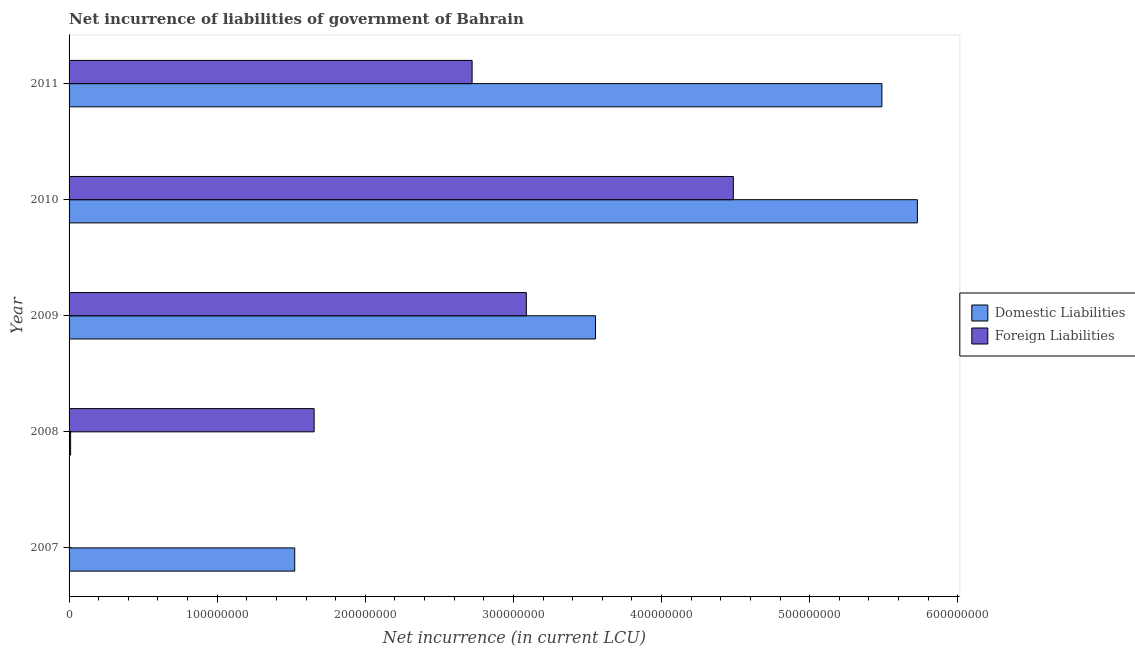How many different coloured bars are there?
Your answer should be compact. 2. How many bars are there on the 5th tick from the bottom?
Keep it short and to the point. 2. What is the net incurrence of domestic liabilities in 2011?
Provide a succinct answer. 5.49e+08. Across all years, what is the maximum net incurrence of foreign liabilities?
Provide a succinct answer. 4.48e+08. What is the total net incurrence of foreign liabilities in the graph?
Your answer should be very brief. 1.19e+09. What is the difference between the net incurrence of domestic liabilities in 2007 and that in 2008?
Keep it short and to the point. 1.51e+08. What is the difference between the net incurrence of domestic liabilities in 2008 and the net incurrence of foreign liabilities in 2010?
Provide a short and direct response. -4.47e+08. What is the average net incurrence of foreign liabilities per year?
Your answer should be compact. 2.39e+08. In the year 2009, what is the difference between the net incurrence of foreign liabilities and net incurrence of domestic liabilities?
Your answer should be compact. -4.67e+07. What is the ratio of the net incurrence of domestic liabilities in 2008 to that in 2011?
Your answer should be compact. 0. Is the net incurrence of foreign liabilities in 2010 less than that in 2011?
Offer a terse response. No. Is the difference between the net incurrence of domestic liabilities in 2009 and 2011 greater than the difference between the net incurrence of foreign liabilities in 2009 and 2011?
Provide a short and direct response. No. What is the difference between the highest and the second highest net incurrence of domestic liabilities?
Make the answer very short. 2.40e+07. What is the difference between the highest and the lowest net incurrence of domestic liabilities?
Ensure brevity in your answer.  5.72e+08. Is the sum of the net incurrence of domestic liabilities in 2009 and 2011 greater than the maximum net incurrence of foreign liabilities across all years?
Provide a short and direct response. Yes. How many years are there in the graph?
Ensure brevity in your answer.  5. Does the graph contain any zero values?
Keep it short and to the point. Yes. Where does the legend appear in the graph?
Provide a succinct answer. Center right. What is the title of the graph?
Your answer should be very brief. Net incurrence of liabilities of government of Bahrain. What is the label or title of the X-axis?
Your response must be concise. Net incurrence (in current LCU). What is the Net incurrence (in current LCU) in Domestic Liabilities in 2007?
Your answer should be compact. 1.52e+08. What is the Net incurrence (in current LCU) of Domestic Liabilities in 2008?
Your answer should be very brief. 1.04e+06. What is the Net incurrence (in current LCU) of Foreign Liabilities in 2008?
Keep it short and to the point. 1.65e+08. What is the Net incurrence (in current LCU) of Domestic Liabilities in 2009?
Make the answer very short. 3.55e+08. What is the Net incurrence (in current LCU) in Foreign Liabilities in 2009?
Keep it short and to the point. 3.09e+08. What is the Net incurrence (in current LCU) of Domestic Liabilities in 2010?
Keep it short and to the point. 5.73e+08. What is the Net incurrence (in current LCU) of Foreign Liabilities in 2010?
Make the answer very short. 4.48e+08. What is the Net incurrence (in current LCU) of Domestic Liabilities in 2011?
Keep it short and to the point. 5.49e+08. What is the Net incurrence (in current LCU) in Foreign Liabilities in 2011?
Your response must be concise. 2.72e+08. Across all years, what is the maximum Net incurrence (in current LCU) in Domestic Liabilities?
Ensure brevity in your answer.  5.73e+08. Across all years, what is the maximum Net incurrence (in current LCU) of Foreign Liabilities?
Keep it short and to the point. 4.48e+08. Across all years, what is the minimum Net incurrence (in current LCU) in Domestic Liabilities?
Provide a short and direct response. 1.04e+06. What is the total Net incurrence (in current LCU) of Domestic Liabilities in the graph?
Provide a short and direct response. 1.63e+09. What is the total Net incurrence (in current LCU) in Foreign Liabilities in the graph?
Keep it short and to the point. 1.19e+09. What is the difference between the Net incurrence (in current LCU) in Domestic Liabilities in 2007 and that in 2008?
Offer a very short reply. 1.51e+08. What is the difference between the Net incurrence (in current LCU) of Domestic Liabilities in 2007 and that in 2009?
Ensure brevity in your answer.  -2.03e+08. What is the difference between the Net incurrence (in current LCU) of Domestic Liabilities in 2007 and that in 2010?
Offer a very short reply. -4.20e+08. What is the difference between the Net incurrence (in current LCU) of Domestic Liabilities in 2007 and that in 2011?
Give a very brief answer. -3.96e+08. What is the difference between the Net incurrence (in current LCU) of Domestic Liabilities in 2008 and that in 2009?
Make the answer very short. -3.54e+08. What is the difference between the Net incurrence (in current LCU) of Foreign Liabilities in 2008 and that in 2009?
Ensure brevity in your answer.  -1.43e+08. What is the difference between the Net incurrence (in current LCU) of Domestic Liabilities in 2008 and that in 2010?
Offer a very short reply. -5.72e+08. What is the difference between the Net incurrence (in current LCU) in Foreign Liabilities in 2008 and that in 2010?
Ensure brevity in your answer.  -2.83e+08. What is the difference between the Net incurrence (in current LCU) of Domestic Liabilities in 2008 and that in 2011?
Provide a succinct answer. -5.48e+08. What is the difference between the Net incurrence (in current LCU) in Foreign Liabilities in 2008 and that in 2011?
Make the answer very short. -1.07e+08. What is the difference between the Net incurrence (in current LCU) in Domestic Liabilities in 2009 and that in 2010?
Make the answer very short. -2.17e+08. What is the difference between the Net incurrence (in current LCU) in Foreign Liabilities in 2009 and that in 2010?
Provide a succinct answer. -1.40e+08. What is the difference between the Net incurrence (in current LCU) in Domestic Liabilities in 2009 and that in 2011?
Your answer should be very brief. -1.93e+08. What is the difference between the Net incurrence (in current LCU) of Foreign Liabilities in 2009 and that in 2011?
Your answer should be very brief. 3.66e+07. What is the difference between the Net incurrence (in current LCU) in Domestic Liabilities in 2010 and that in 2011?
Keep it short and to the point. 2.40e+07. What is the difference between the Net incurrence (in current LCU) of Foreign Liabilities in 2010 and that in 2011?
Give a very brief answer. 1.76e+08. What is the difference between the Net incurrence (in current LCU) in Domestic Liabilities in 2007 and the Net incurrence (in current LCU) in Foreign Liabilities in 2008?
Give a very brief answer. -1.31e+07. What is the difference between the Net incurrence (in current LCU) in Domestic Liabilities in 2007 and the Net incurrence (in current LCU) in Foreign Liabilities in 2009?
Your response must be concise. -1.56e+08. What is the difference between the Net incurrence (in current LCU) of Domestic Liabilities in 2007 and the Net incurrence (in current LCU) of Foreign Liabilities in 2010?
Give a very brief answer. -2.96e+08. What is the difference between the Net incurrence (in current LCU) in Domestic Liabilities in 2007 and the Net incurrence (in current LCU) in Foreign Liabilities in 2011?
Provide a short and direct response. -1.20e+08. What is the difference between the Net incurrence (in current LCU) in Domestic Liabilities in 2008 and the Net incurrence (in current LCU) in Foreign Liabilities in 2009?
Ensure brevity in your answer.  -3.08e+08. What is the difference between the Net incurrence (in current LCU) of Domestic Liabilities in 2008 and the Net incurrence (in current LCU) of Foreign Liabilities in 2010?
Your answer should be very brief. -4.47e+08. What is the difference between the Net incurrence (in current LCU) in Domestic Liabilities in 2008 and the Net incurrence (in current LCU) in Foreign Liabilities in 2011?
Your answer should be compact. -2.71e+08. What is the difference between the Net incurrence (in current LCU) in Domestic Liabilities in 2009 and the Net incurrence (in current LCU) in Foreign Liabilities in 2010?
Make the answer very short. -9.30e+07. What is the difference between the Net incurrence (in current LCU) of Domestic Liabilities in 2009 and the Net incurrence (in current LCU) of Foreign Liabilities in 2011?
Offer a very short reply. 8.33e+07. What is the difference between the Net incurrence (in current LCU) in Domestic Liabilities in 2010 and the Net incurrence (in current LCU) in Foreign Liabilities in 2011?
Provide a succinct answer. 3.01e+08. What is the average Net incurrence (in current LCU) in Domestic Liabilities per year?
Your answer should be very brief. 3.26e+08. What is the average Net incurrence (in current LCU) in Foreign Liabilities per year?
Provide a short and direct response. 2.39e+08. In the year 2008, what is the difference between the Net incurrence (in current LCU) of Domestic Liabilities and Net incurrence (in current LCU) of Foreign Liabilities?
Provide a succinct answer. -1.64e+08. In the year 2009, what is the difference between the Net incurrence (in current LCU) of Domestic Liabilities and Net incurrence (in current LCU) of Foreign Liabilities?
Give a very brief answer. 4.67e+07. In the year 2010, what is the difference between the Net incurrence (in current LCU) in Domestic Liabilities and Net incurrence (in current LCU) in Foreign Liabilities?
Keep it short and to the point. 1.24e+08. In the year 2011, what is the difference between the Net incurrence (in current LCU) in Domestic Liabilities and Net incurrence (in current LCU) in Foreign Liabilities?
Give a very brief answer. 2.77e+08. What is the ratio of the Net incurrence (in current LCU) of Domestic Liabilities in 2007 to that in 2008?
Keep it short and to the point. 146.47. What is the ratio of the Net incurrence (in current LCU) in Domestic Liabilities in 2007 to that in 2009?
Provide a succinct answer. 0.43. What is the ratio of the Net incurrence (in current LCU) in Domestic Liabilities in 2007 to that in 2010?
Keep it short and to the point. 0.27. What is the ratio of the Net incurrence (in current LCU) in Domestic Liabilities in 2007 to that in 2011?
Give a very brief answer. 0.28. What is the ratio of the Net incurrence (in current LCU) in Domestic Liabilities in 2008 to that in 2009?
Provide a succinct answer. 0. What is the ratio of the Net incurrence (in current LCU) in Foreign Liabilities in 2008 to that in 2009?
Offer a terse response. 0.54. What is the ratio of the Net incurrence (in current LCU) of Domestic Liabilities in 2008 to that in 2010?
Your response must be concise. 0. What is the ratio of the Net incurrence (in current LCU) in Foreign Liabilities in 2008 to that in 2010?
Make the answer very short. 0.37. What is the ratio of the Net incurrence (in current LCU) in Domestic Liabilities in 2008 to that in 2011?
Give a very brief answer. 0. What is the ratio of the Net incurrence (in current LCU) of Foreign Liabilities in 2008 to that in 2011?
Ensure brevity in your answer.  0.61. What is the ratio of the Net incurrence (in current LCU) of Domestic Liabilities in 2009 to that in 2010?
Offer a terse response. 0.62. What is the ratio of the Net incurrence (in current LCU) of Foreign Liabilities in 2009 to that in 2010?
Ensure brevity in your answer.  0.69. What is the ratio of the Net incurrence (in current LCU) in Domestic Liabilities in 2009 to that in 2011?
Your answer should be compact. 0.65. What is the ratio of the Net incurrence (in current LCU) of Foreign Liabilities in 2009 to that in 2011?
Offer a terse response. 1.13. What is the ratio of the Net incurrence (in current LCU) in Domestic Liabilities in 2010 to that in 2011?
Your response must be concise. 1.04. What is the ratio of the Net incurrence (in current LCU) in Foreign Liabilities in 2010 to that in 2011?
Provide a succinct answer. 1.65. What is the difference between the highest and the second highest Net incurrence (in current LCU) in Domestic Liabilities?
Your response must be concise. 2.40e+07. What is the difference between the highest and the second highest Net incurrence (in current LCU) of Foreign Liabilities?
Provide a short and direct response. 1.40e+08. What is the difference between the highest and the lowest Net incurrence (in current LCU) in Domestic Liabilities?
Ensure brevity in your answer.  5.72e+08. What is the difference between the highest and the lowest Net incurrence (in current LCU) in Foreign Liabilities?
Your response must be concise. 4.48e+08. 